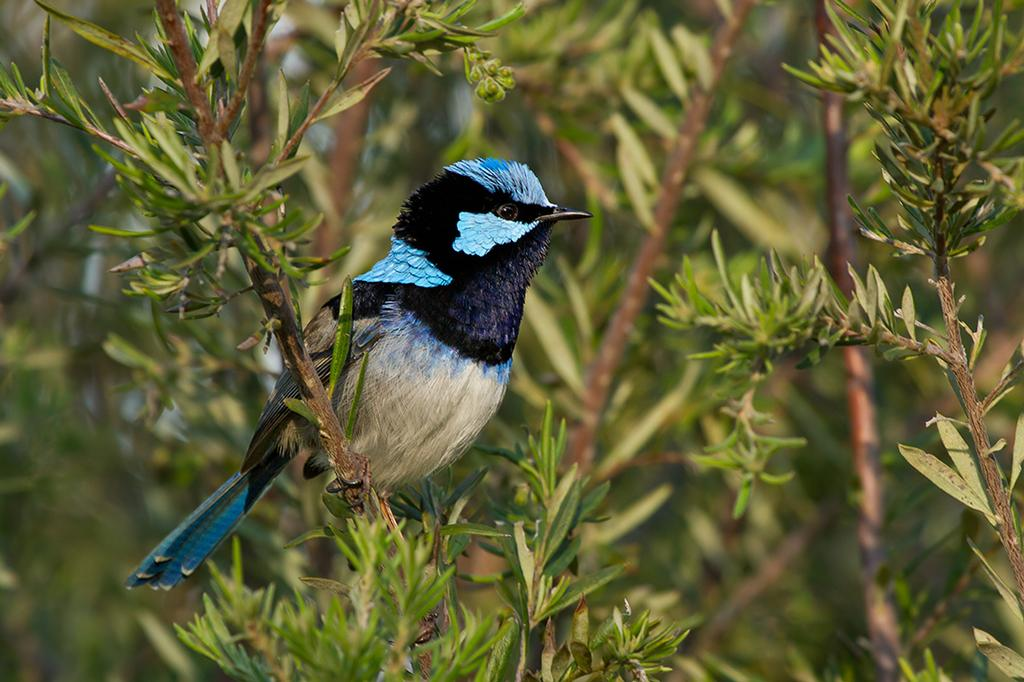What type of animal is in the image? There is a bird in the image. Where is the bird located? The bird is on a plant. Can you describe the background of the image? The background of the image is blurred. What else can be seen in the background of the image? There are plants visible in the background of the image. Where is the basin located in the image? There is no basin present in the image. What type of toy can be seen interacting with the bird in the image? There is no toy present in the image; it features a bird on a plant. 